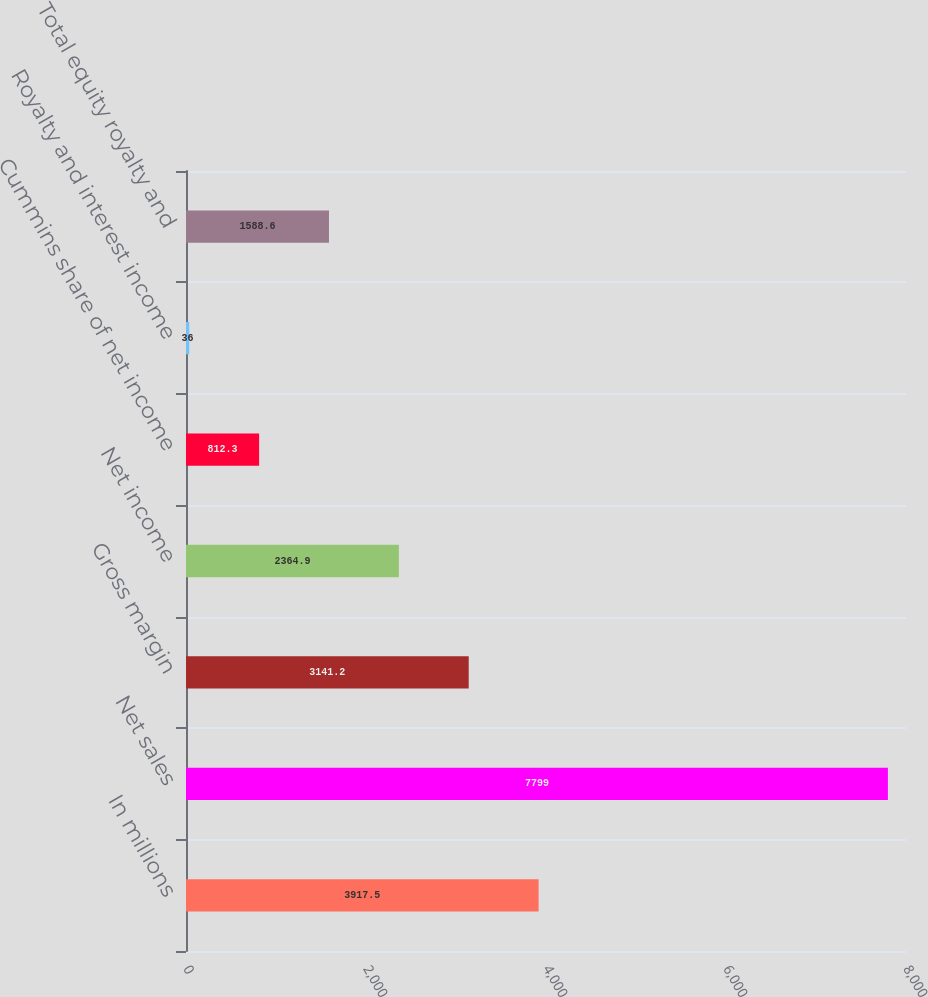<chart> <loc_0><loc_0><loc_500><loc_500><bar_chart><fcel>In millions<fcel>Net sales<fcel>Gross margin<fcel>Net income<fcel>Cummins share of net income<fcel>Royalty and interest income<fcel>Total equity royalty and<nl><fcel>3917.5<fcel>7799<fcel>3141.2<fcel>2364.9<fcel>812.3<fcel>36<fcel>1588.6<nl></chart> 